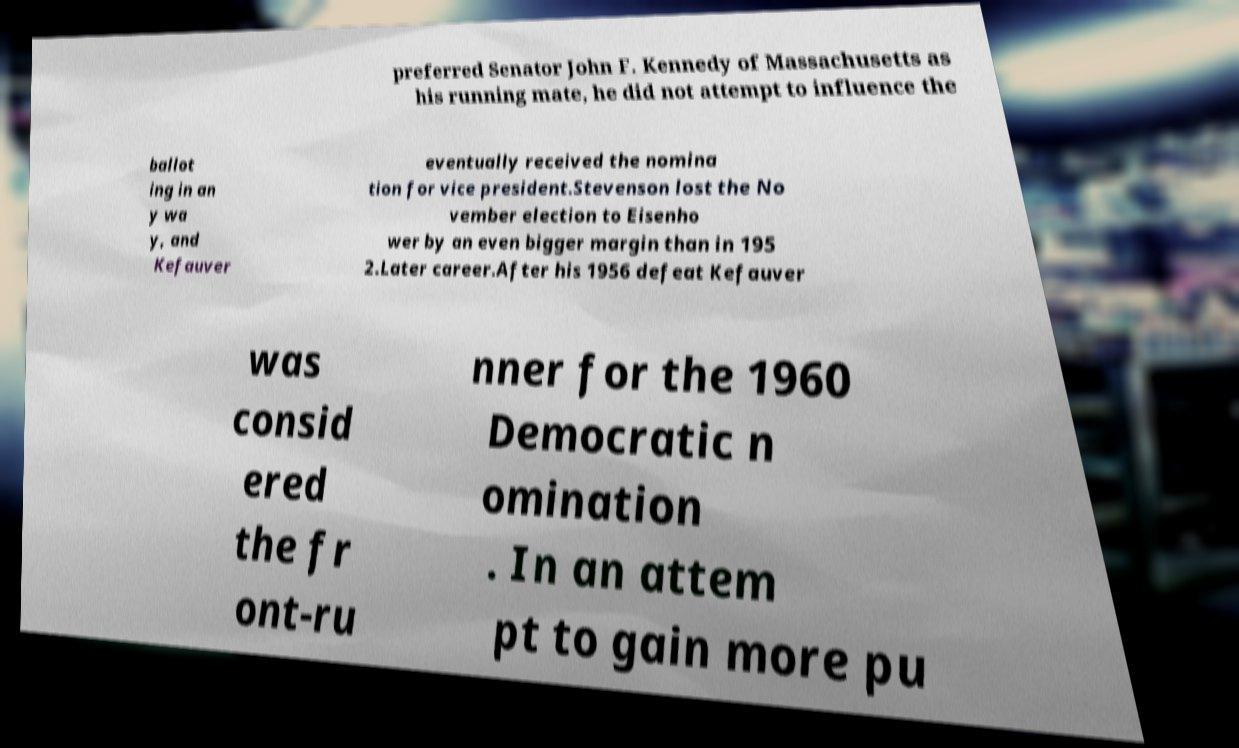I need the written content from this picture converted into text. Can you do that? preferred Senator John F. Kennedy of Massachusetts as his running mate, he did not attempt to influence the ballot ing in an y wa y, and Kefauver eventually received the nomina tion for vice president.Stevenson lost the No vember election to Eisenho wer by an even bigger margin than in 195 2.Later career.After his 1956 defeat Kefauver was consid ered the fr ont-ru nner for the 1960 Democratic n omination . In an attem pt to gain more pu 